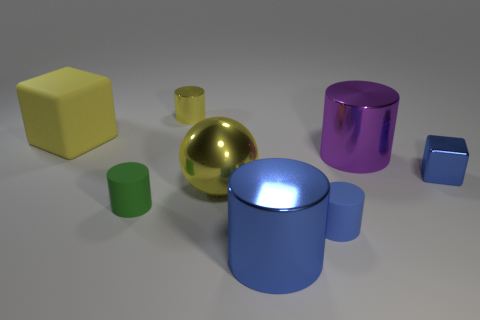Is the metallic sphere the same size as the green rubber cylinder?
Provide a succinct answer. No. Is there anything else that is the same shape as the big yellow shiny thing?
Your answer should be very brief. No. Is the material of the large object in front of the yellow shiny ball the same as the big ball?
Your response must be concise. Yes. What is the shape of the rubber object that is to the right of the yellow matte block and to the left of the small yellow object?
Make the answer very short. Cylinder. Are there any metallic things that are behind the rubber object that is behind the metallic cube?
Keep it short and to the point. Yes. What number of other things are there of the same material as the purple cylinder
Offer a terse response. 4. There is a large yellow thing on the left side of the green cylinder; is it the same shape as the tiny metallic thing that is in front of the big cube?
Provide a short and direct response. Yes. Does the small blue cylinder have the same material as the yellow cube?
Provide a short and direct response. Yes. There is a cylinder that is in front of the small cylinder to the right of the small shiny object that is behind the large purple thing; how big is it?
Your answer should be compact. Large. How many other things are there of the same color as the small shiny cylinder?
Your answer should be very brief. 2. 